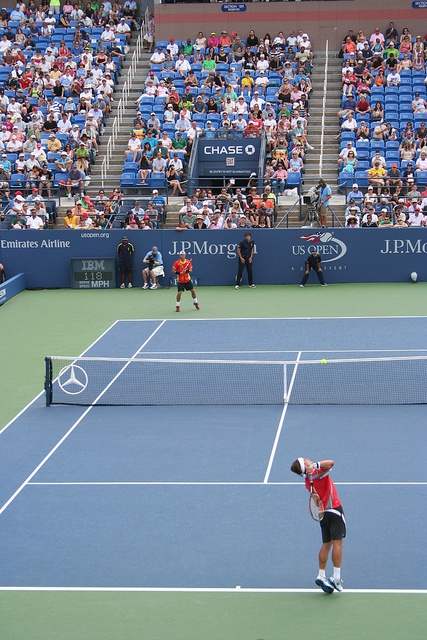Describe the objects in this image and their specific colors. I can see people in brown, gray, black, darkgray, and lavender tones, people in brown, black, and gray tones, people in brown, black, darkgray, and maroon tones, people in brown, black, navy, and gray tones, and people in brown, black, gray, lightgray, and darkgray tones in this image. 